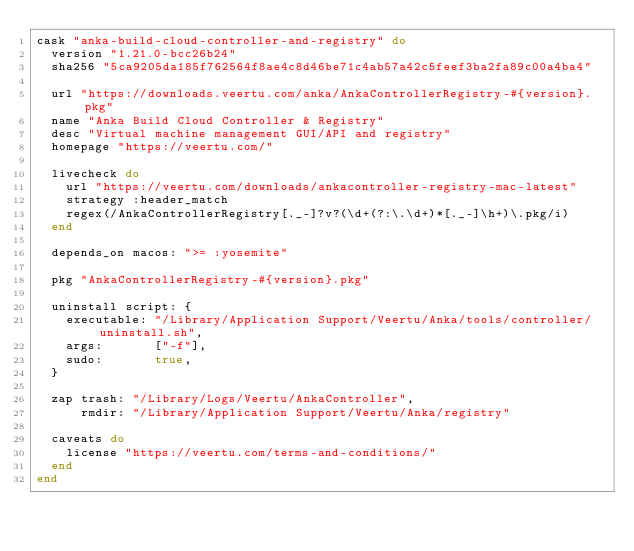Convert code to text. <code><loc_0><loc_0><loc_500><loc_500><_Ruby_>cask "anka-build-cloud-controller-and-registry" do
  version "1.21.0-bcc26b24"
  sha256 "5ca9205da185f762564f8ae4c8d46be71c4ab57a42c5feef3ba2fa89c00a4ba4"

  url "https://downloads.veertu.com/anka/AnkaControllerRegistry-#{version}.pkg"
  name "Anka Build Cloud Controller & Registry"
  desc "Virtual machine management GUI/API and registry"
  homepage "https://veertu.com/"

  livecheck do
    url "https://veertu.com/downloads/ankacontroller-registry-mac-latest"
    strategy :header_match
    regex(/AnkaControllerRegistry[._-]?v?(\d+(?:\.\d+)*[._-]\h+)\.pkg/i)
  end

  depends_on macos: ">= :yosemite"

  pkg "AnkaControllerRegistry-#{version}.pkg"

  uninstall script: {
    executable: "/Library/Application Support/Veertu/Anka/tools/controller/uninstall.sh",
    args:       ["-f"],
    sudo:       true,
  }

  zap trash: "/Library/Logs/Veertu/AnkaController",
      rmdir: "/Library/Application Support/Veertu/Anka/registry"

  caveats do
    license "https://veertu.com/terms-and-conditions/"
  end
end
</code> 